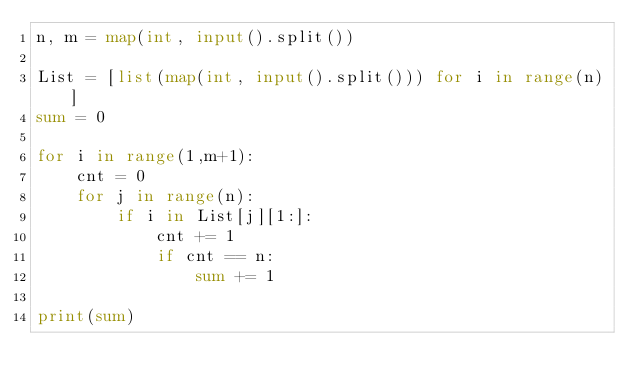<code> <loc_0><loc_0><loc_500><loc_500><_Python_>n, m = map(int, input().split())

List = [list(map(int, input().split())) for i in range(n)]
sum = 0

for i in range(1,m+1):
    cnt = 0
    for j in range(n):
        if i in List[j][1:]:
            cnt += 1
            if cnt == n:
                sum += 1

print(sum)</code> 